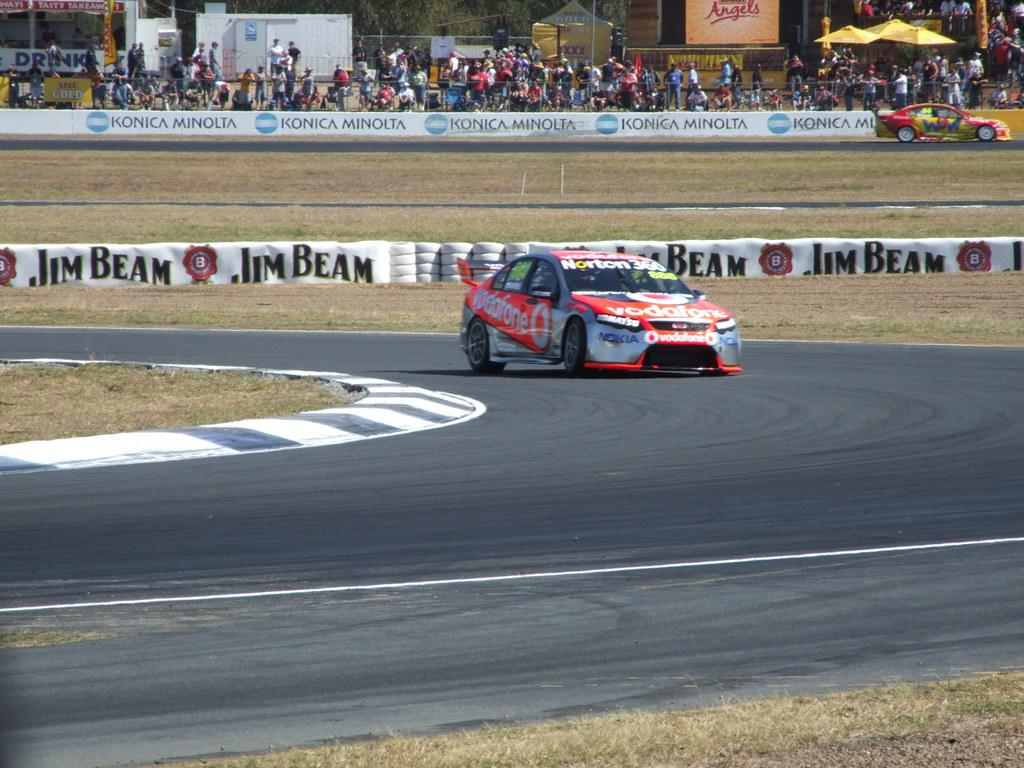What is on the road in the image? There is a car on the road in the image. What type of vegetation can be seen in the image? There is grass visible in the image. What are the banners used for in the image? The purpose of the banners in the image is not specified, but they are likely used for advertising or decoration. What can be seen on the ground in the image? There are tyres visible in the image. What type of sand can be seen in the image? There is no sand present in the image. How many yards are visible in the image? There is no yard present in the image. 